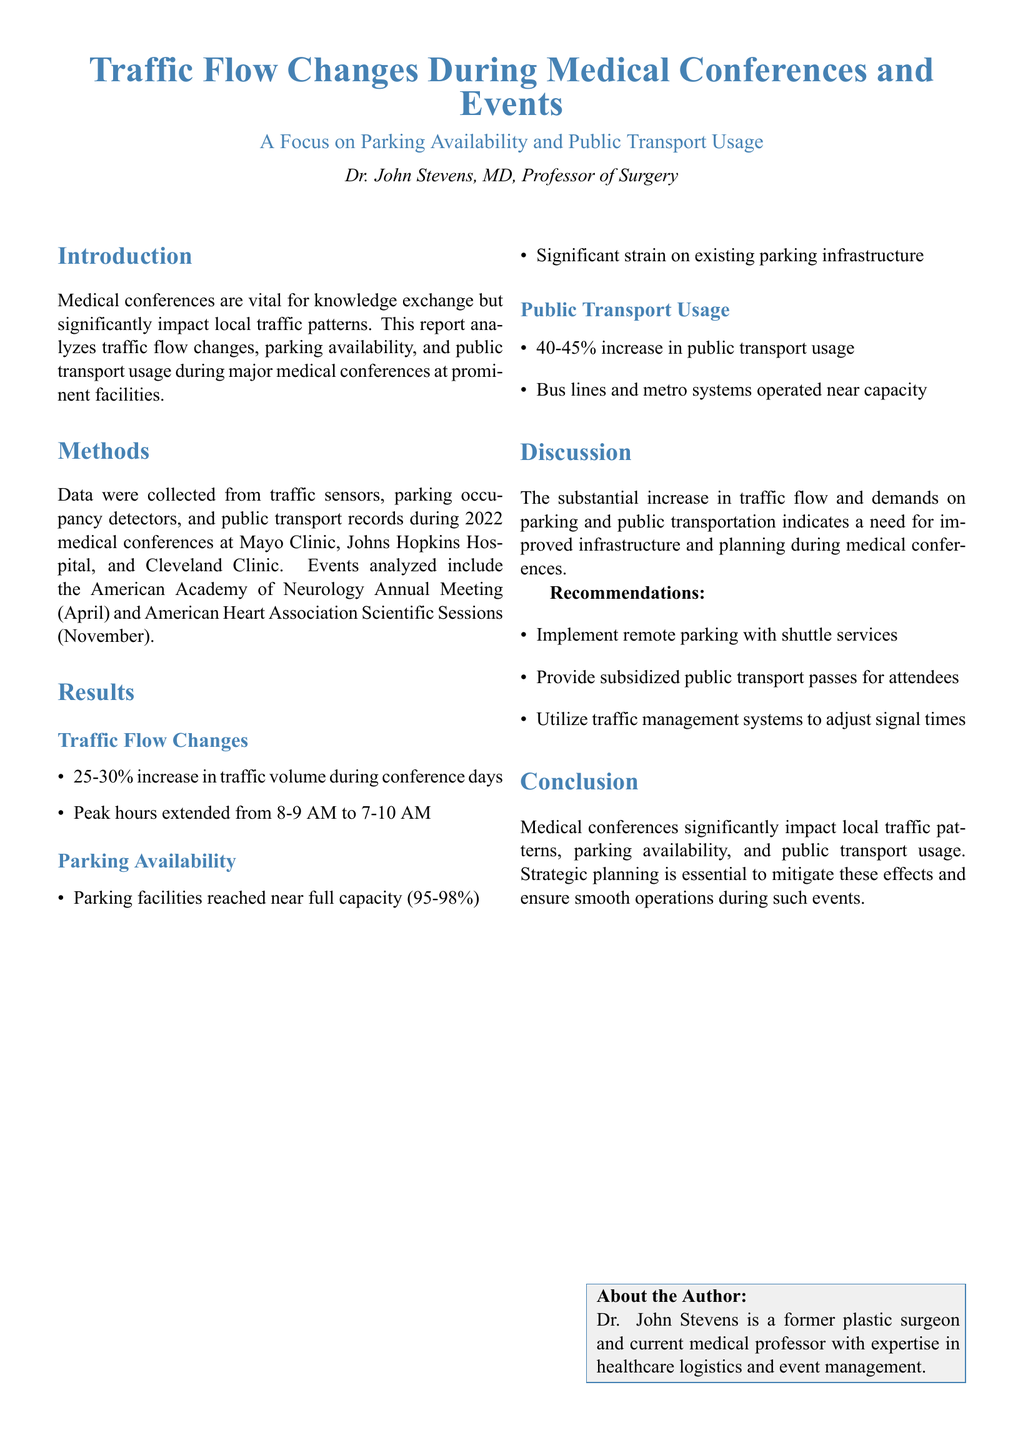What is the title of the report? The title of the report is stated at the beginning of the document, clearly detailing the focus on traffic flow changes during medical events.
Answer: Traffic Flow Changes During Medical Conferences and Events Who is the author of the document? The author is introduced in the header of the document, providing their name and credentials.
Answer: Dr. John Stevens What percentage increase in traffic volume was observed during conference days? The report specifies the range of traffic increase during the analysis of medical conferences, highlighting significant changes.
Answer: 25-30% What was the parking facility capacity during the events? The document mentions the parking availability status during the conferences, indicating how full the facilities were.
Answer: 95-98% What percentage increase in public transport usage was recorded? The report provides a specific statistic concerning the rise in public transportation usage during the conference periods.
Answer: 40-45% What are the recommended actions for handling traffic issues? Recommendations for improving traffic flow and infrastructure during medical conferences are outlined in the discussion section.
Answer: Implement remote parking with shuttle services What was the extended peak traffic hour range during conferences? The document discusses how peak traffic hours changed as a result of the conferences, providing specific time frames.
Answer: 7-10 AM What two major events were analyzed in this report? The report lists the specific medical conferences that were the focus of this traffic flow study, identifying them directly in the methods section.
Answer: American Academy of Neurology Annual Meeting and American Heart Association Scientific Sessions 